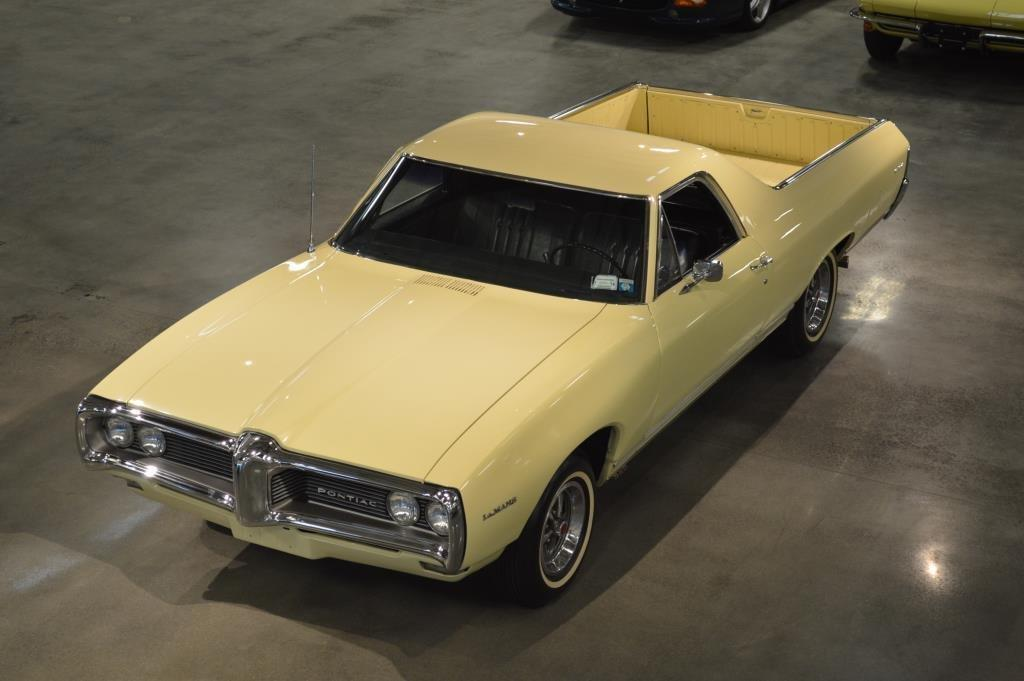What types of objects are in the image? There are vehicles in the image. Where are the vehicles located? The vehicles are on the ground. Can you describe one of the vehicles in the image? There is a yellow car in the image. How many clovers can be seen growing near the vehicles in the image? There are no clovers visible in the image; it only features vehicles on the ground. 